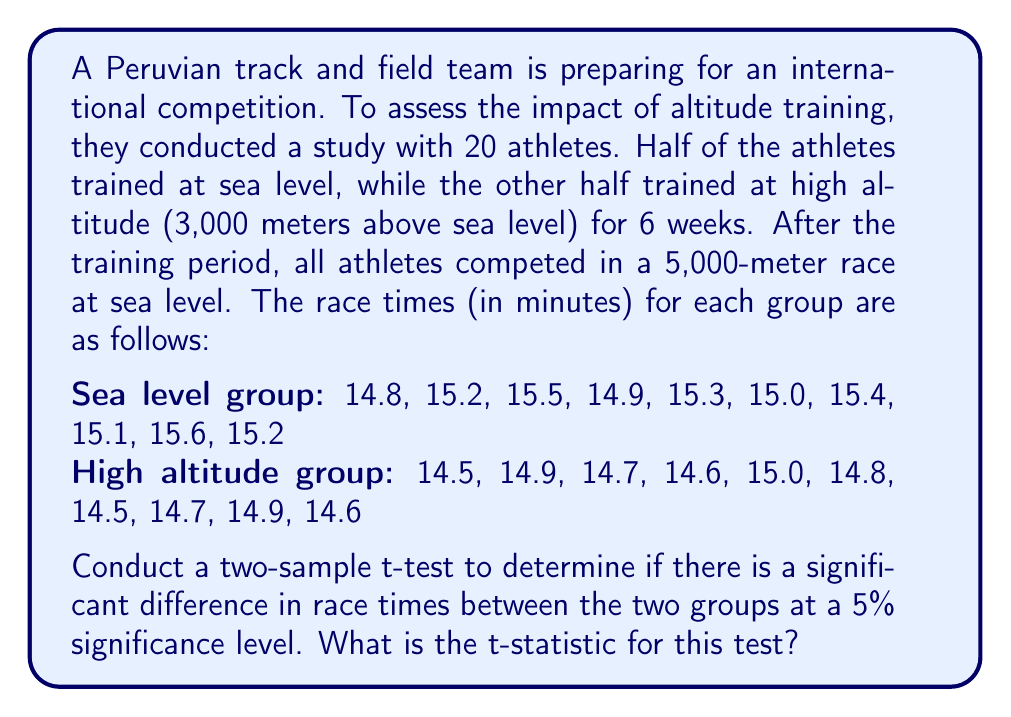Teach me how to tackle this problem. To conduct a two-sample t-test, we need to follow these steps:

1. Calculate the means and standard deviations for both groups:

Sea level group:
$\bar{x}_1 = \frac{14.8 + 15.2 + 15.5 + 14.9 + 15.3 + 15.0 + 15.4 + 15.1 + 15.6 + 15.2}{10} = 15.2$

$s_1 = \sqrt{\frac{\sum (x_i - \bar{x}_1)^2}{n_1 - 1}} = 0.2608$

High altitude group:
$\bar{x}_2 = \frac{14.5 + 14.9 + 14.7 + 14.6 + 15.0 + 14.8 + 14.5 + 14.7 + 14.9 + 14.6}{10} = 14.72$

$s_2 = \sqrt{\frac{\sum (x_i - \bar{x}_2)^2}{n_2 - 1}} = 0.1874$

2. Calculate the pooled standard deviation:

$s_p = \sqrt{\frac{(n_1 - 1)s_1^2 + (n_2 - 1)s_2^2}{n_1 + n_2 - 2}}$

$s_p = \sqrt{\frac{(10 - 1)(0.2608)^2 + (10 - 1)(0.1874)^2}{10 + 10 - 2}} = 0.2270$

3. Calculate the t-statistic:

$t = \frac{\bar{x}_1 - \bar{x}_2}{s_p\sqrt{\frac{2}{n}}}$

Where $n = 10$ (sample size for each group)

$t = \frac{15.2 - 14.72}{0.2270\sqrt{\frac{2}{10}}} = \frac{0.48}{0.1014} = 4.7337$

Therefore, the t-statistic for this test is approximately 4.7337.
Answer: $t \approx 4.7337$ 